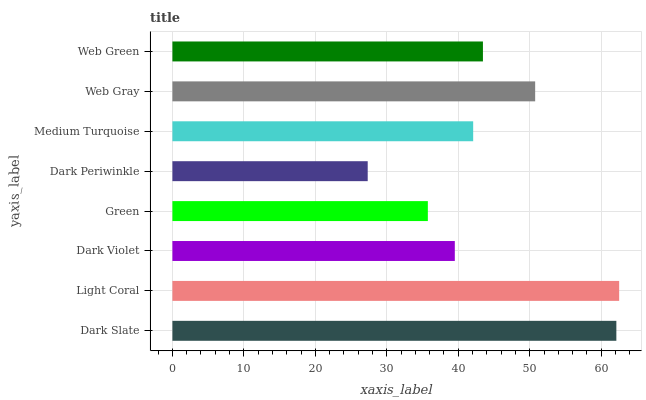Is Dark Periwinkle the minimum?
Answer yes or no. Yes. Is Light Coral the maximum?
Answer yes or no. Yes. Is Dark Violet the minimum?
Answer yes or no. No. Is Dark Violet the maximum?
Answer yes or no. No. Is Light Coral greater than Dark Violet?
Answer yes or no. Yes. Is Dark Violet less than Light Coral?
Answer yes or no. Yes. Is Dark Violet greater than Light Coral?
Answer yes or no. No. Is Light Coral less than Dark Violet?
Answer yes or no. No. Is Web Green the high median?
Answer yes or no. Yes. Is Medium Turquoise the low median?
Answer yes or no. Yes. Is Dark Slate the high median?
Answer yes or no. No. Is Light Coral the low median?
Answer yes or no. No. 